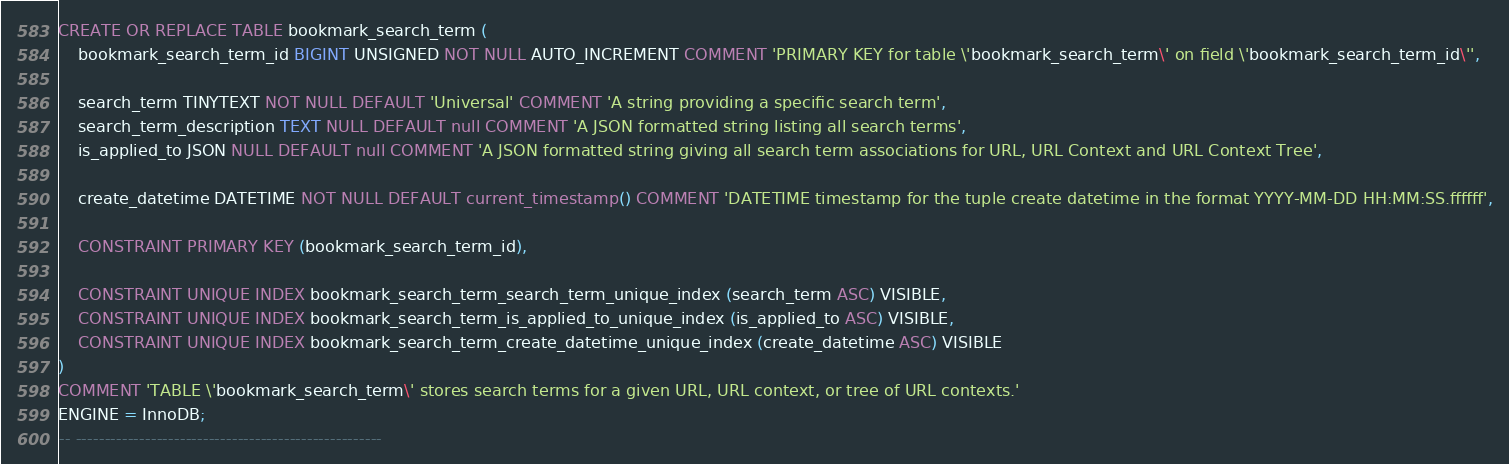<code> <loc_0><loc_0><loc_500><loc_500><_SQL_>
CREATE OR REPLACE TABLE bookmark_search_term (
	bookmark_search_term_id BIGINT UNSIGNED NOT NULL AUTO_INCREMENT COMMENT 'PRIMARY KEY for table \'bookmark_search_term\' on field \'bookmark_search_term_id\'',

	search_term TINYTEXT NOT NULL DEFAULT 'Universal' COMMENT 'A string providing a specific search term',
	search_term_description TEXT NULL DEFAULT null COMMENT 'A JSON formatted string listing all search terms',
	is_applied_to JSON NULL DEFAULT null COMMENT 'A JSON formatted string giving all search term associations for URL, URL Context and URL Context Tree',

	create_datetime DATETIME NOT NULL DEFAULT current_timestamp() COMMENT 'DATETIME timestamp for the tuple create datetime in the format YYYY-MM-DD HH:MM:SS.ffffff',

	CONSTRAINT PRIMARY KEY (bookmark_search_term_id),

	CONSTRAINT UNIQUE INDEX bookmark_search_term_search_term_unique_index (search_term ASC) VISIBLE,
	CONSTRAINT UNIQUE INDEX bookmark_search_term_is_applied_to_unique_index (is_applied_to ASC) VISIBLE,
	CONSTRAINT UNIQUE INDEX bookmark_search_term_create_datetime_unique_index (create_datetime ASC) VISIBLE
)
COMMENT 'TABLE \'bookmark_search_term\' stores search terms for a given URL, URL context, or tree of URL contexts.'
ENGINE = InnoDB;
-- -----------------------------------------------------</code> 